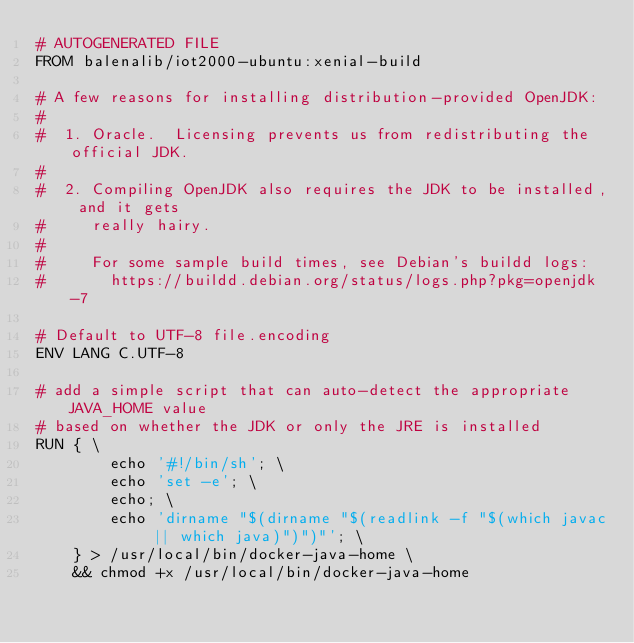Convert code to text. <code><loc_0><loc_0><loc_500><loc_500><_Dockerfile_># AUTOGENERATED FILE
FROM balenalib/iot2000-ubuntu:xenial-build

# A few reasons for installing distribution-provided OpenJDK:
#
#  1. Oracle.  Licensing prevents us from redistributing the official JDK.
#
#  2. Compiling OpenJDK also requires the JDK to be installed, and it gets
#     really hairy.
#
#     For some sample build times, see Debian's buildd logs:
#       https://buildd.debian.org/status/logs.php?pkg=openjdk-7

# Default to UTF-8 file.encoding
ENV LANG C.UTF-8

# add a simple script that can auto-detect the appropriate JAVA_HOME value
# based on whether the JDK or only the JRE is installed
RUN { \
		echo '#!/bin/sh'; \
		echo 'set -e'; \
		echo; \
		echo 'dirname "$(dirname "$(readlink -f "$(which javac || which java)")")"'; \
	} > /usr/local/bin/docker-java-home \
	&& chmod +x /usr/local/bin/docker-java-home
</code> 